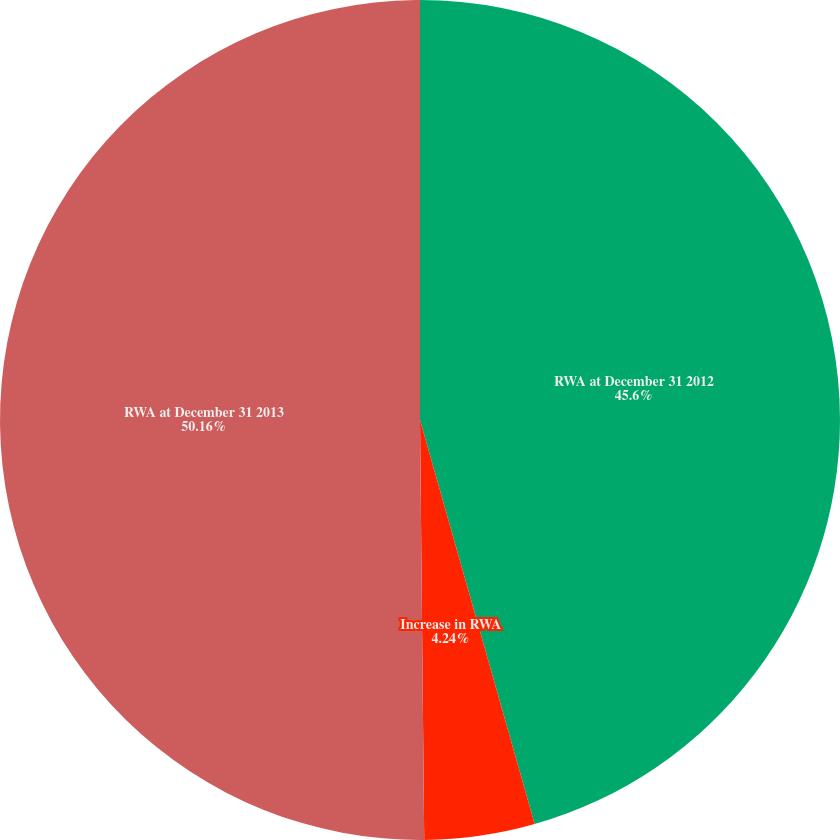<chart> <loc_0><loc_0><loc_500><loc_500><pie_chart><fcel>RWA at December 31 2012<fcel>Increase in RWA<fcel>RWA at December 31 2013<nl><fcel>45.6%<fcel>4.24%<fcel>50.16%<nl></chart> 